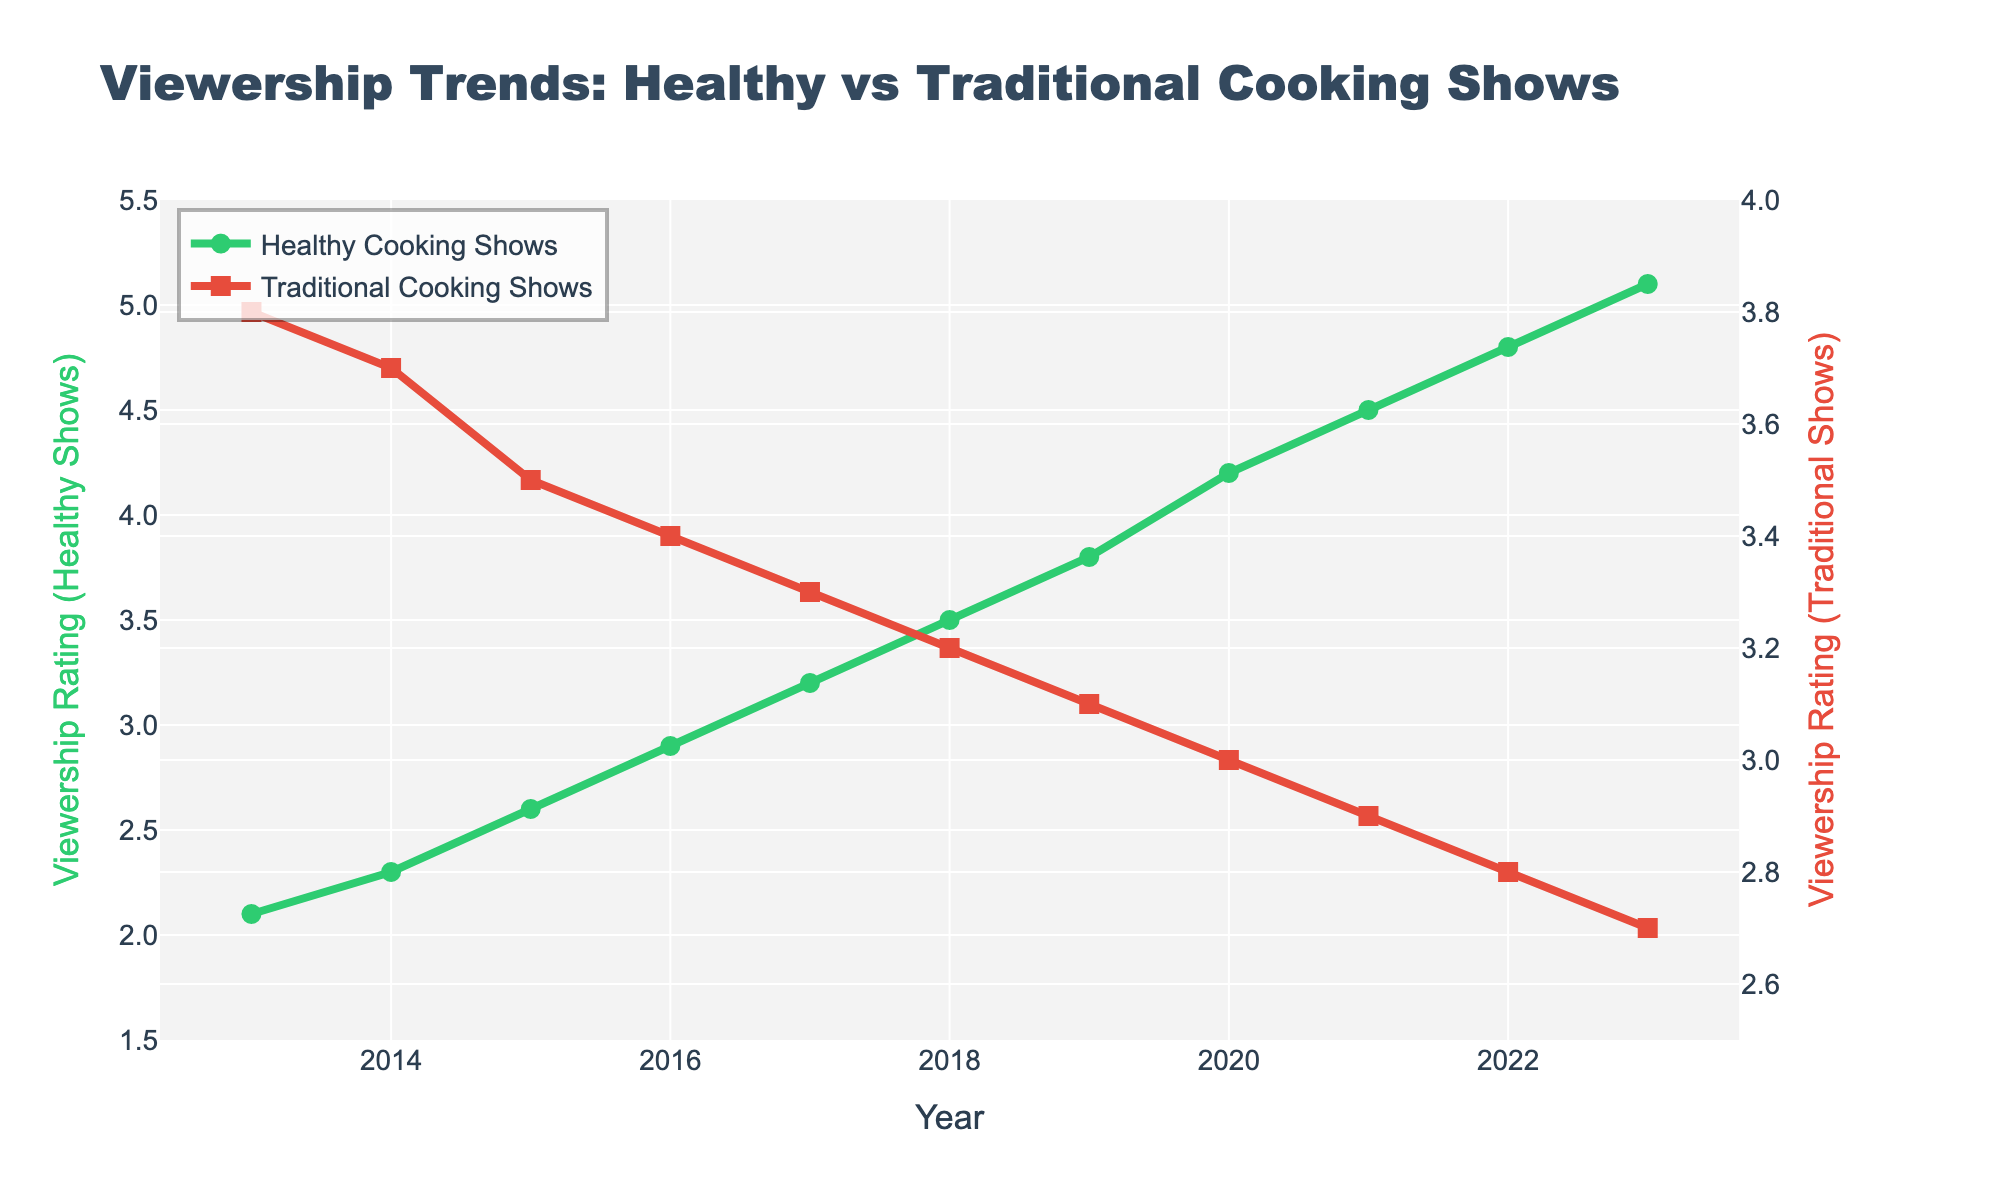Which type of cooking show had higher viewership ratings in 2013? Comparing the points on the line plot for both types of cooking shows in 2013, Traditional Cooking Shows had a rating of 3.8, whereas Healthy Cooking Shows had a rating of 2.1. So, Traditional Cooking Shows had higher ratings.
Answer: Traditional Cooking Shows How did the viewership of Healthy Cooking Shows change between 2018 and 2023? Observing the points on the line plot for Healthy Cooking Shows, the rating increased from 3.5 in 2018 to 5.1 in 2023. This indicates a rise in viewership over these years.
Answer: Increased In which year did Healthy Cooking Shows first surpass Traditional Cooking Shows in viewership ratings? By examining the intersection point on the line plot, we see that Healthy Cooking Shows first surpassed Traditional Cooking Shows in 2017, where the ratings were 3.2 for Healthy Cooking Shows and 3.3 for Traditional Cooking Shows just before the crossing point.
Answer: 2017 What is the average viewership rating for Healthy Cooking Shows from 2013 to 2023? Calculating the average by summing the ratings for Healthy Cooking Shows (2.1 + 2.3 + 2.6 + 2.9 + 3.2 + 3.5 + 3.8 + 4.2 + 4.5 + 4.8 + 5.1) gives a total of 38. That sum divided by 11 years averages to approximately 3.45.
Answer: 3.45 By how much did the viewership rating of Traditional Cooking Shows decrease from 2013 to 2023? The viewership rating for Traditional Cooking Shows decreased from 3.8 in 2013 to 2.7 in 2023. The difference is 3.8 - 2.7 = 1.1.
Answer: 1.1 What can be said about the trend of Traditional Cooking Shows' ratings over the decade? Observing the plotted line for Traditional Cooking Shows from 2013 to 2023, the viewership ratings consistently declined each year from 3.8 to 2.7, indicating a downward trend.
Answer: Decreasing trend Which year had the highest viewership rating for Healthy Cooking Shows, and what was the rating? Looking at the highest point on the line plot for Healthy Cooking Shows, the peak occurs in 2023 with a rating of 5.1.
Answer: 2023, 5.1 What is the general trend observed in Healthy Cooking Shows' ratings from 2013 to 2023? The line plot for Healthy Cooking Shows shows a steady increase in viewership ratings from 2.1 in 2013 to 5.1 in 2023.
Answer: Increasing trend 